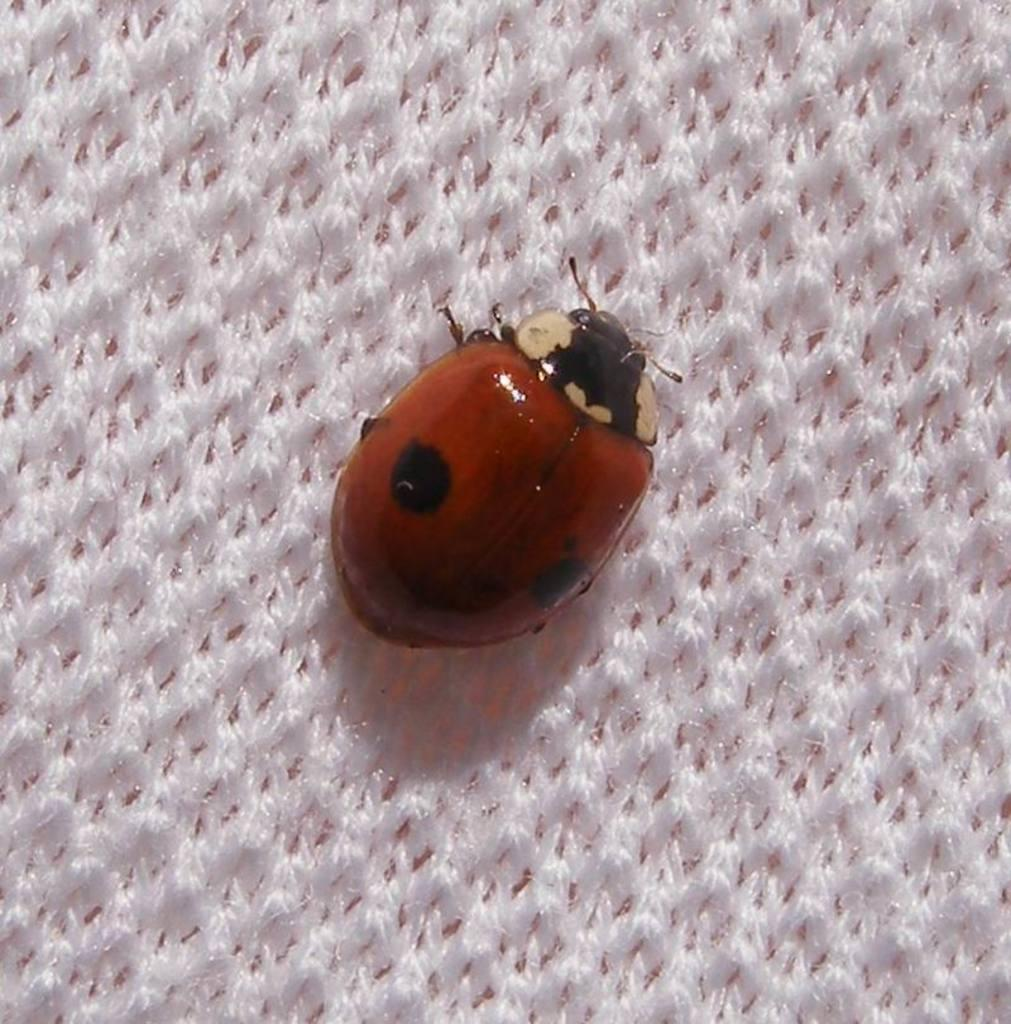What type of creature is present in the image? There is an insect in the image. Where is the insect located? The insect is on a cloth. What language is the insect speaking in the image? Insects do not speak languages, so this question cannot be answered. 